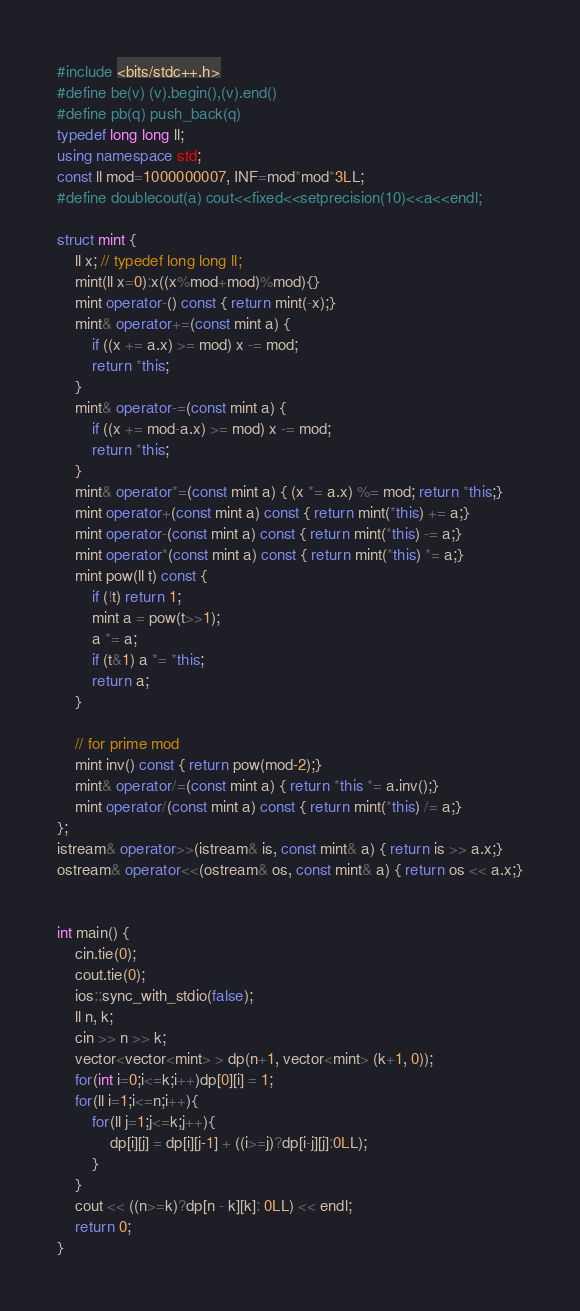Convert code to text. <code><loc_0><loc_0><loc_500><loc_500><_C++_>#include <bits/stdc++.h>
#define be(v) (v).begin(),(v).end()
#define pb(q) push_back(q)
typedef long long ll;
using namespace std;
const ll mod=1000000007, INF=mod*mod*3LL;
#define doublecout(a) cout<<fixed<<setprecision(10)<<a<<endl;

struct mint {
    ll x; // typedef long long ll;
    mint(ll x=0):x((x%mod+mod)%mod){}
    mint operator-() const { return mint(-x);}
    mint& operator+=(const mint a) {
        if ((x += a.x) >= mod) x -= mod;
        return *this;
    }
    mint& operator-=(const mint a) {
        if ((x += mod-a.x) >= mod) x -= mod;
        return *this;
    }
    mint& operator*=(const mint a) { (x *= a.x) %= mod; return *this;}
    mint operator+(const mint a) const { return mint(*this) += a;}
    mint operator-(const mint a) const { return mint(*this) -= a;}
    mint operator*(const mint a) const { return mint(*this) *= a;}
    mint pow(ll t) const {
        if (!t) return 1;
        mint a = pow(t>>1);
        a *= a;
        if (t&1) a *= *this;
        return a;
    }

    // for prime mod
    mint inv() const { return pow(mod-2);}
    mint& operator/=(const mint a) { return *this *= a.inv();}
    mint operator/(const mint a) const { return mint(*this) /= a;}
};
istream& operator>>(istream& is, const mint& a) { return is >> a.x;}
ostream& operator<<(ostream& os, const mint& a) { return os << a.x;}


int main() {
    cin.tie(0);
    cout.tie(0);
    ios::sync_with_stdio(false);
    ll n, k;
    cin >> n >> k;
    vector<vector<mint> > dp(n+1, vector<mint> (k+1, 0));
    for(int i=0;i<=k;i++)dp[0][i] = 1;
    for(ll i=1;i<=n;i++){
    	for(ll j=1;j<=k;j++){
    		dp[i][j] = dp[i][j-1] + ((i>=j)?dp[i-j][j]:0LL);
    	}
    }
    cout << ((n>=k)?dp[n - k][k]: 0LL) << endl;
    return 0;
}

</code> 